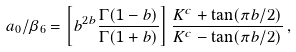<formula> <loc_0><loc_0><loc_500><loc_500>a _ { 0 } / \beta _ { 6 } = \left [ b ^ { 2 b } \frac { \Gamma ( 1 - b ) } { \Gamma ( 1 + b ) } \right ] \frac { K ^ { c } + \tan ( \pi b / 2 ) } { K ^ { c } - \tan ( \pi b / 2 ) } \, ,</formula> 